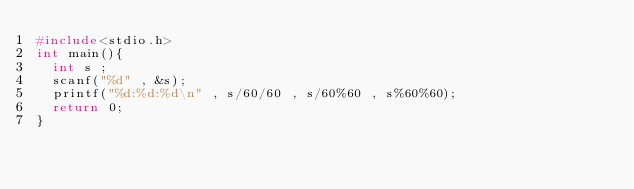Convert code to text. <code><loc_0><loc_0><loc_500><loc_500><_C_>#include<stdio.h>
int main(){
  int s ;
  scanf("%d" , &s);
  printf("%d:%d:%d\n" , s/60/60 , s/60%60 , s%60%60);
  return 0;
}

</code> 